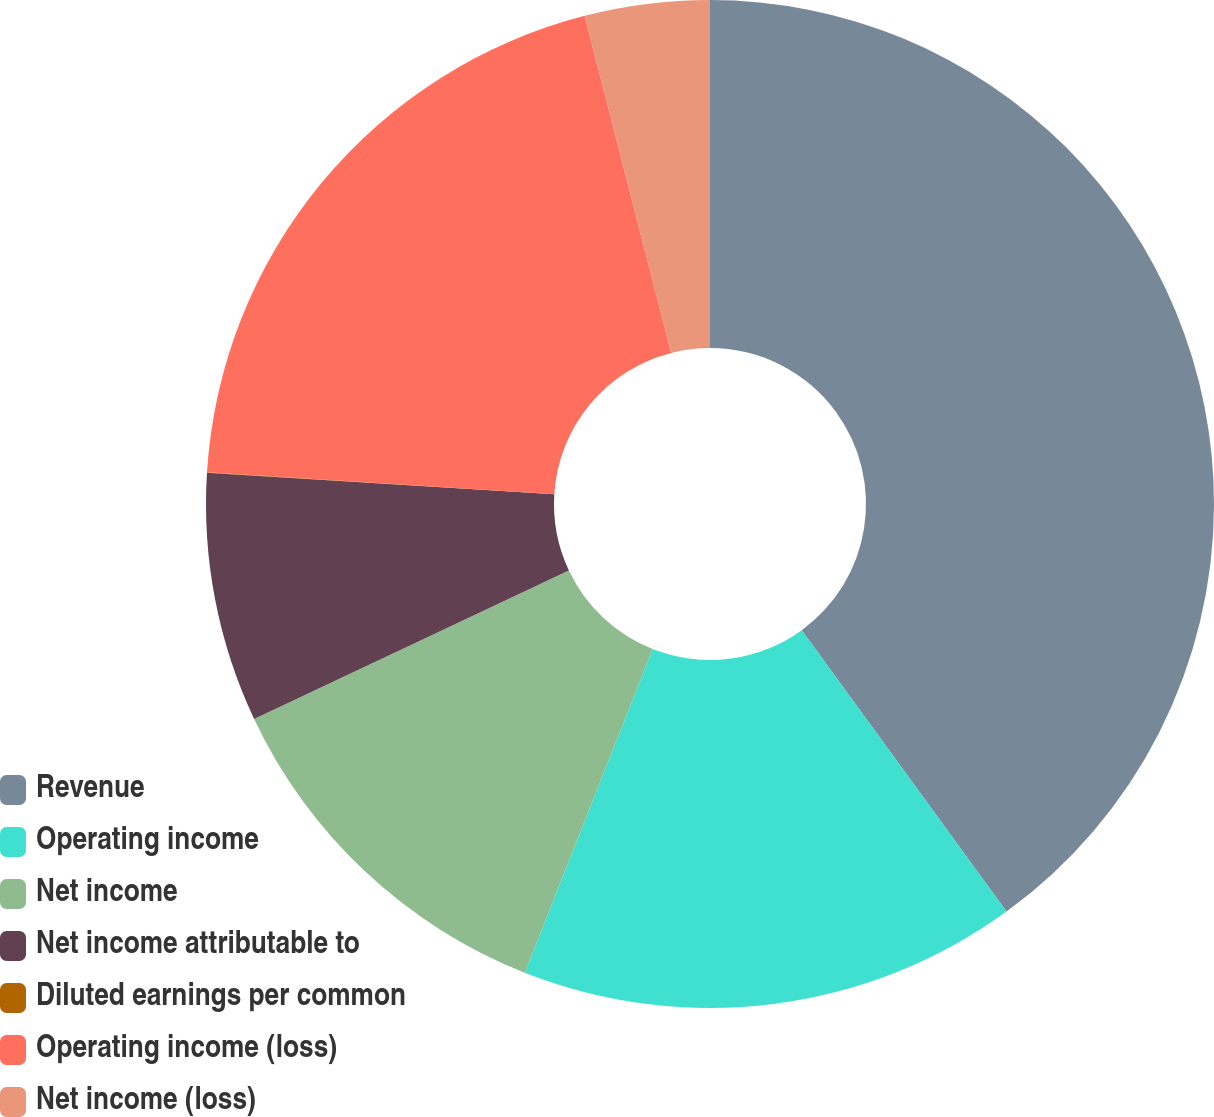Convert chart to OTSL. <chart><loc_0><loc_0><loc_500><loc_500><pie_chart><fcel>Revenue<fcel>Operating income<fcel>Net income<fcel>Net income attributable to<fcel>Diluted earnings per common<fcel>Operating income (loss)<fcel>Net income (loss)<nl><fcel>39.99%<fcel>16.0%<fcel>12.0%<fcel>8.0%<fcel>0.01%<fcel>20.0%<fcel>4.0%<nl></chart> 